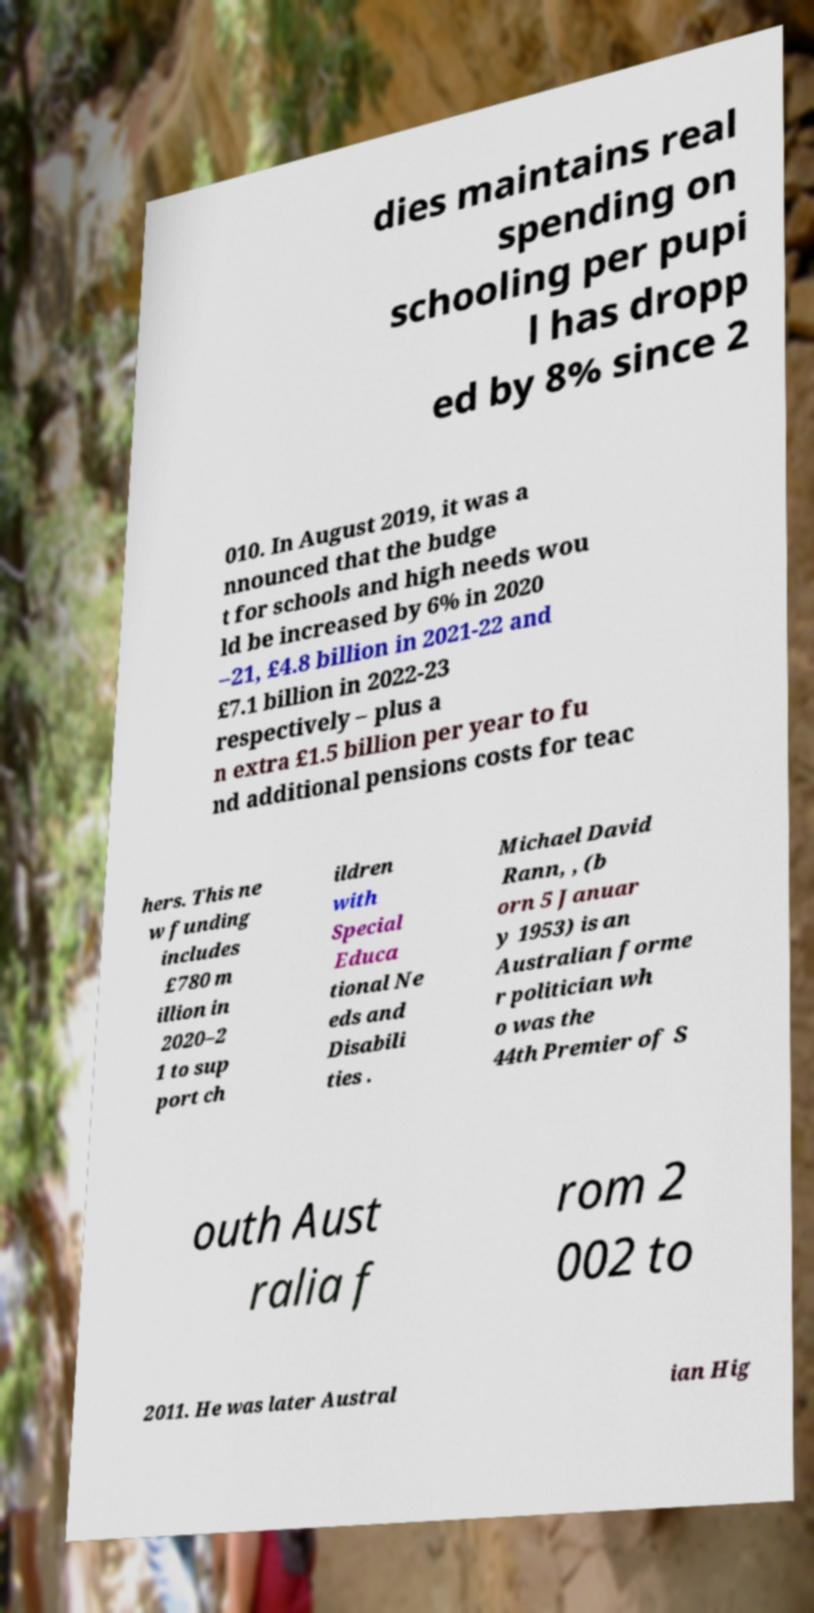Can you accurately transcribe the text from the provided image for me? dies maintains real spending on schooling per pupi l has dropp ed by 8% since 2 010. In August 2019, it was a nnounced that the budge t for schools and high needs wou ld be increased by 6% in 2020 –21, £4.8 billion in 2021-22 and £7.1 billion in 2022-23 respectively – plus a n extra £1.5 billion per year to fu nd additional pensions costs for teac hers. This ne w funding includes £780 m illion in 2020–2 1 to sup port ch ildren with Special Educa tional Ne eds and Disabili ties . Michael David Rann, , (b orn 5 Januar y 1953) is an Australian forme r politician wh o was the 44th Premier of S outh Aust ralia f rom 2 002 to 2011. He was later Austral ian Hig 